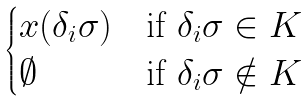Convert formula to latex. <formula><loc_0><loc_0><loc_500><loc_500>\begin{cases} x ( \delta _ { i } \sigma ) & \text {if } \delta _ { i } \sigma \in K \\ \emptyset & \text {if } \delta _ { i } \sigma \notin K \end{cases}</formula> 